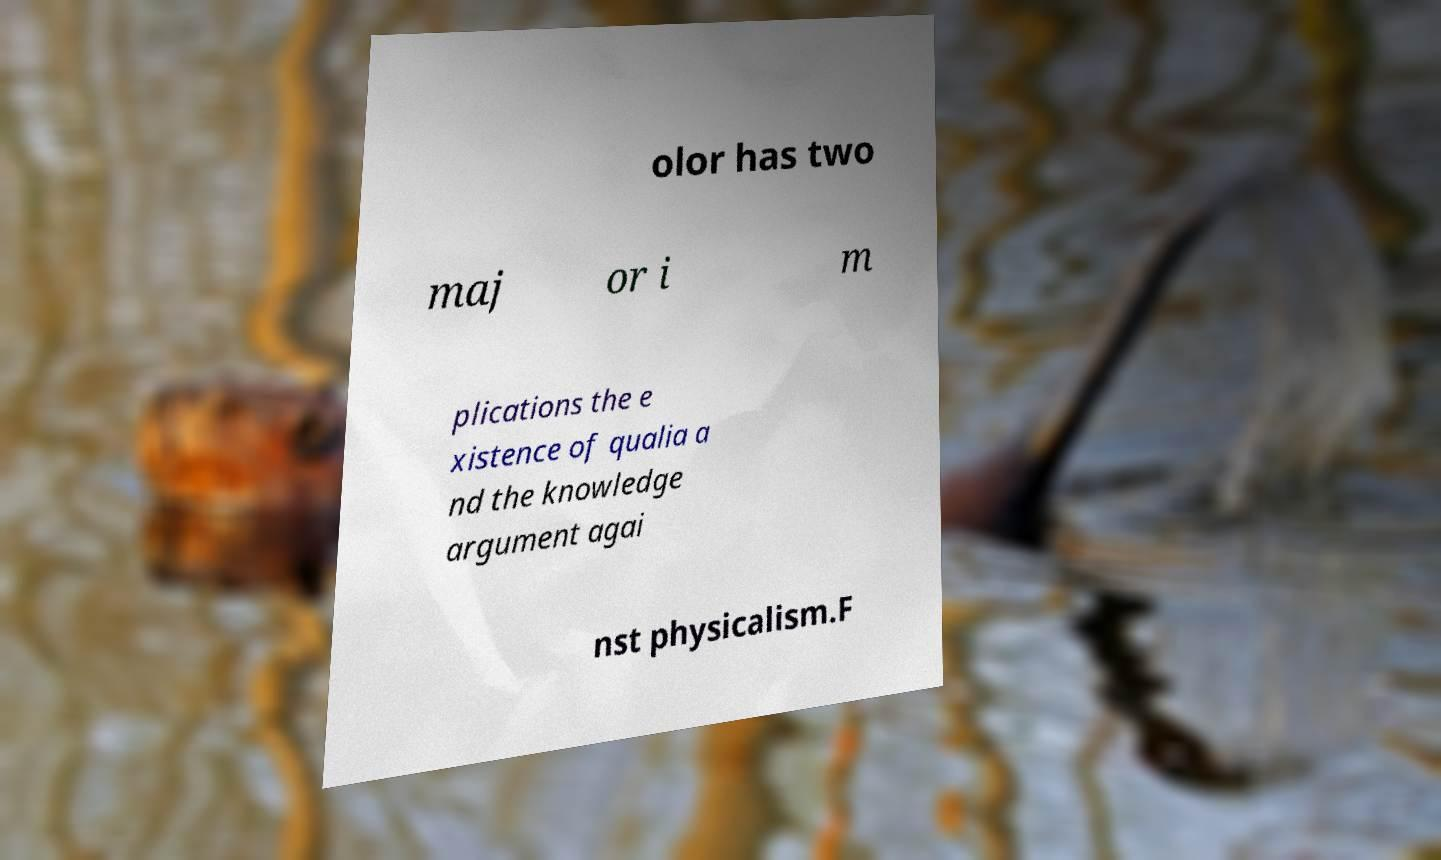Can you accurately transcribe the text from the provided image for me? olor has two maj or i m plications the e xistence of qualia a nd the knowledge argument agai nst physicalism.F 